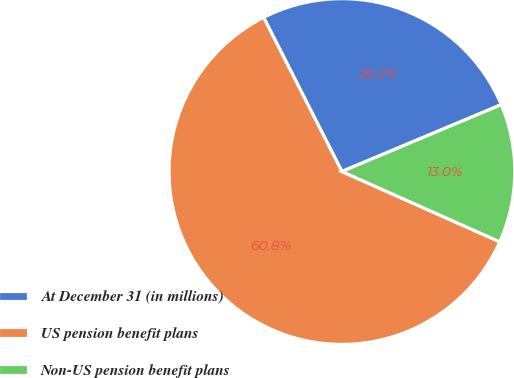Convert chart to OTSL. <chart><loc_0><loc_0><loc_500><loc_500><pie_chart><fcel>At December 31 (in millions)<fcel>US pension benefit plans<fcel>Non-US pension benefit plans<nl><fcel>26.16%<fcel>60.85%<fcel>12.99%<nl></chart> 